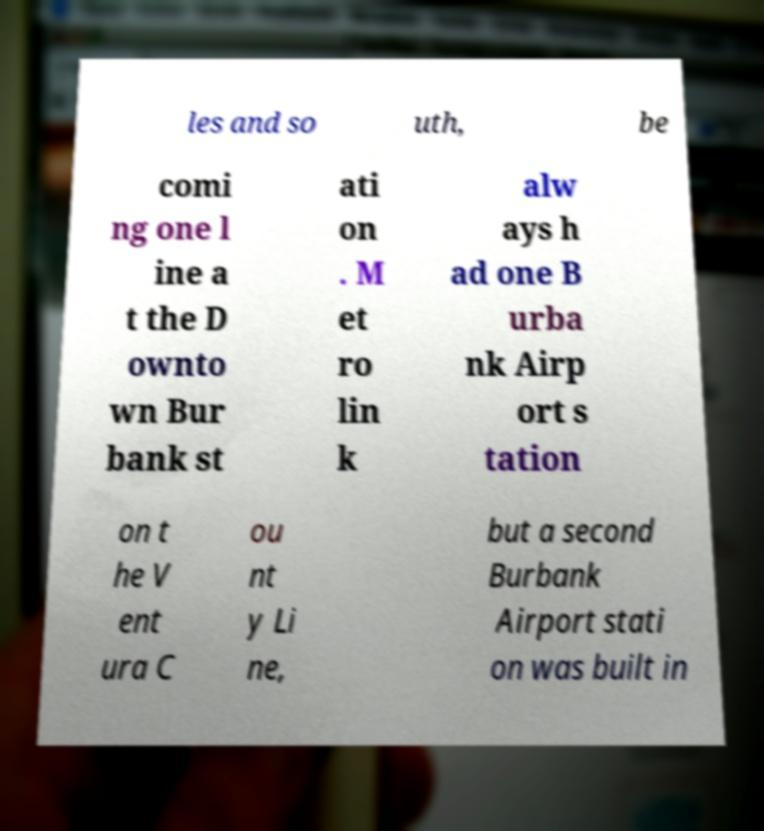What messages or text are displayed in this image? I need them in a readable, typed format. les and so uth, be comi ng one l ine a t the D ownto wn Bur bank st ati on . M et ro lin k alw ays h ad one B urba nk Airp ort s tation on t he V ent ura C ou nt y Li ne, but a second Burbank Airport stati on was built in 